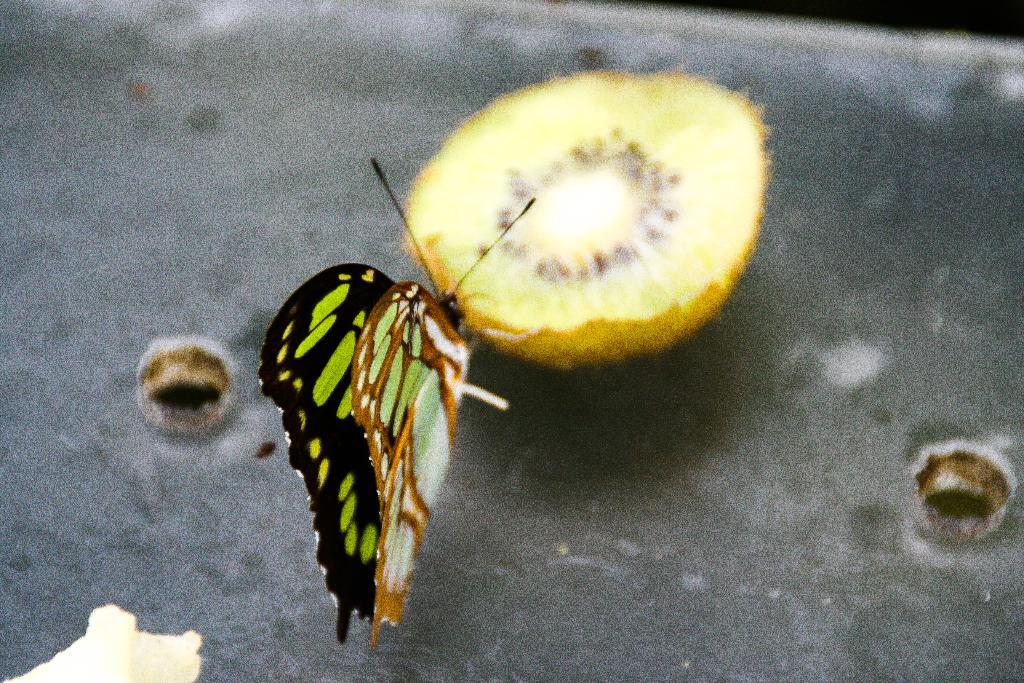What is on the fruit in the image? There is a butterfly on a fruit in the image. What can be seen in the background of the image? There is a box in the background of the image. How many holes are there in the box? The box has two holes. What type of gun is being used by the fairies in the image? There are no fairies or guns present in the image. The image only features a butterfly on a fruit and a box with two holes in the background. 